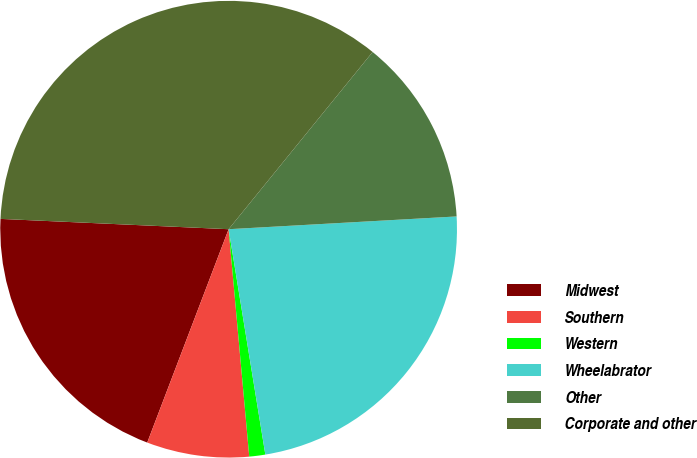Convert chart. <chart><loc_0><loc_0><loc_500><loc_500><pie_chart><fcel>Midwest<fcel>Southern<fcel>Western<fcel>Wheelabrator<fcel>Other<fcel>Corporate and other<nl><fcel>19.92%<fcel>7.24%<fcel>1.13%<fcel>23.32%<fcel>13.25%<fcel>35.14%<nl></chart> 